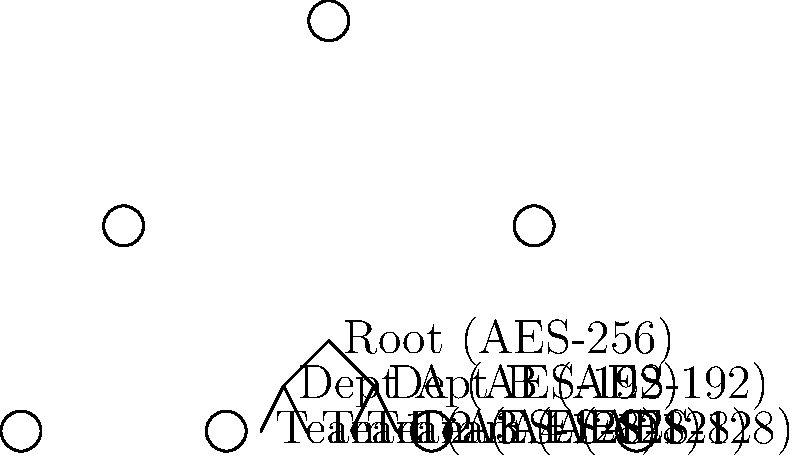In the hierarchical encryption system shown above, what is the minimum number of decryption operations required to access a file stored at the Team 1 level, assuming you start with the Root key? To answer this question, we need to follow these steps:

1. Understand the hierarchical structure:
   - Root level uses AES-256
   - Department level uses AES-192
   - Team level uses AES-128

2. Trace the path from Root to Team 1:
   Root → Dept A → Team 1

3. Count the number of decryption operations:
   a) First, decrypt the Root level using AES-256
   b) Then, decrypt the Dept A level using AES-192
   c) Finally, decrypt the Team 1 level using AES-128

4. Sum up the total number of decryption operations:
   1 (Root) + 1 (Dept A) + 1 (Team 1) = 3 operations

Each level requires one decryption operation, regardless of the specific AES key size used. The hierarchical nature of the encryption system means that to access a lower level, you must first decrypt all the levels above it.
Answer: 3 